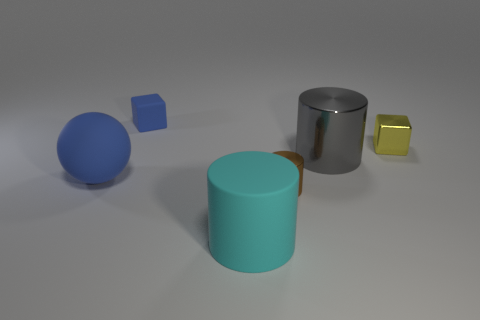Do the sphere and the rubber object behind the large blue thing have the same color?
Offer a very short reply. Yes. There is a rubber object that is the same color as the matte cube; what shape is it?
Offer a terse response. Sphere. Is there a sphere of the same color as the tiny matte object?
Give a very brief answer. Yes. Is there any other thing of the same color as the large ball?
Make the answer very short. Yes. Is the color of the small matte object the same as the matte sphere?
Make the answer very short. Yes. What size is the thing that is the same color as the big ball?
Offer a terse response. Small. Are there any big blue spheres to the right of the big rubber thing that is behind the large cyan cylinder?
Offer a terse response. No. Are there fewer yellow cubes on the left side of the small metallic cylinder than large objects that are on the right side of the yellow block?
Keep it short and to the point. No. Are there any other things that have the same size as the cyan cylinder?
Keep it short and to the point. Yes. There is a large gray shiny thing; what shape is it?
Keep it short and to the point. Cylinder. 